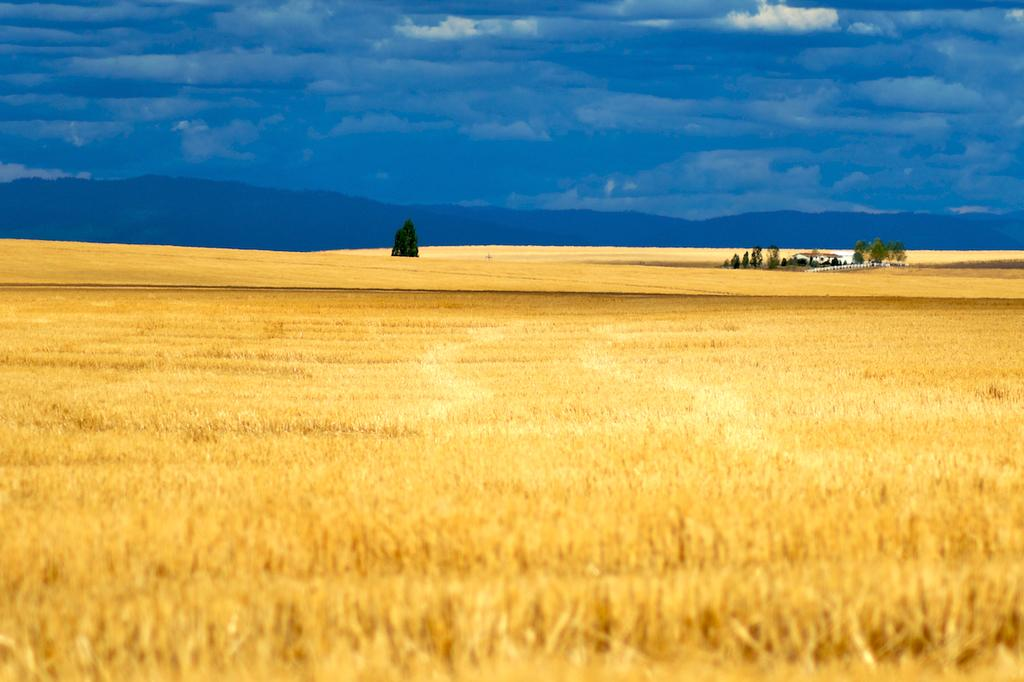What type of vegetation is present in the image? There is dried grass in the image. What is the color of the grass? The grass is brown in color. What can be seen in the background of the image? There are trees in the background of the image. What is the color of the trees? The trees are green in color. What is visible in the sky in the image? The sky is blue and white in color. How does the grass fight against the trees in the image? There is no fighting between the grass and trees in the image; they are simply present in the scene. 